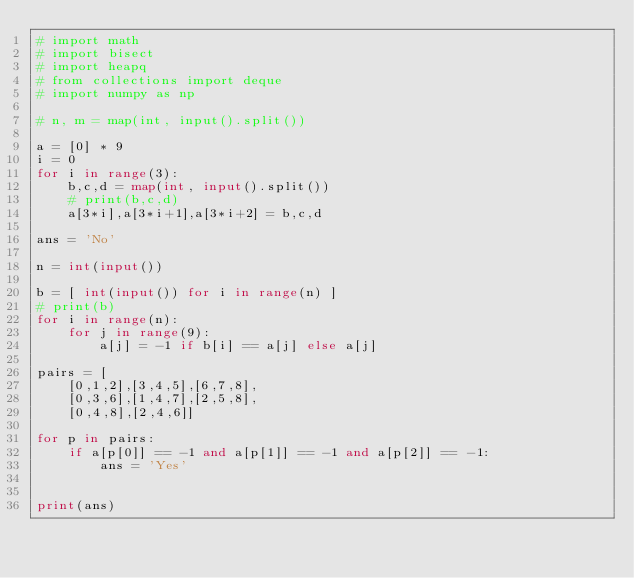<code> <loc_0><loc_0><loc_500><loc_500><_Python_># import math
# import bisect
# import heapq
# from collections import deque
# import numpy as np

# n, m = map(int, input().split())

a = [0] * 9
i = 0
for i in range(3):
    b,c,d = map(int, input().split())
    # print(b,c,d)
    a[3*i],a[3*i+1],a[3*i+2] = b,c,d

ans = 'No'

n = int(input())

b = [ int(input()) for i in range(n) ]
# print(b)
for i in range(n):
    for j in range(9):
        a[j] = -1 if b[i] == a[j] else a[j]

pairs = [
    [0,1,2],[3,4,5],[6,7,8],
    [0,3,6],[1,4,7],[2,5,8],
    [0,4,8],[2,4,6]]

for p in pairs:
    if a[p[0]] == -1 and a[p[1]] == -1 and a[p[2]] == -1:
        ans = 'Yes'


print(ans)</code> 